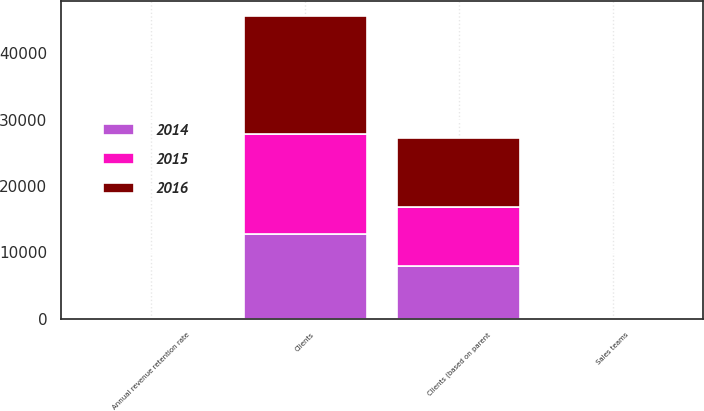Convert chart. <chart><loc_0><loc_0><loc_500><loc_500><stacked_bar_chart><ecel><fcel>Clients<fcel>Clients (based on parent<fcel>Sales teams<fcel>Annual revenue retention rate<nl><fcel>2016<fcel>17817<fcel>10464<fcel>42<fcel>91<nl><fcel>2015<fcel>15004<fcel>8906<fcel>36<fcel>91<nl><fcel>2014<fcel>12775<fcel>7945<fcel>31<fcel>91<nl></chart> 